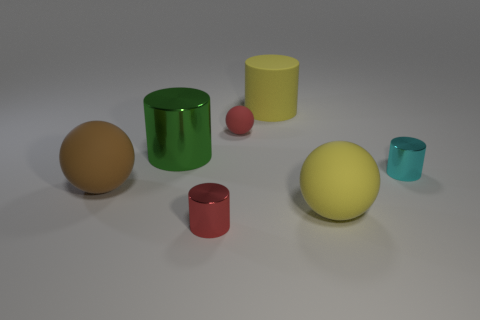Subtract 1 balls. How many balls are left? 2 Add 2 large blue metal things. How many objects exist? 9 Subtract all yellow spheres. How many spheres are left? 2 Subtract all cyan cylinders. How many cylinders are left? 3 Subtract all spheres. How many objects are left? 4 Add 4 cylinders. How many cylinders are left? 8 Add 4 large matte cylinders. How many large matte cylinders exist? 5 Subtract 0 purple cylinders. How many objects are left? 7 Subtract all blue spheres. Subtract all blue blocks. How many spheres are left? 3 Subtract all small red rubber objects. Subtract all cyan cylinders. How many objects are left? 5 